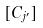<formula> <loc_0><loc_0><loc_500><loc_500>[ C _ { j ^ { \prime } } ]</formula> 